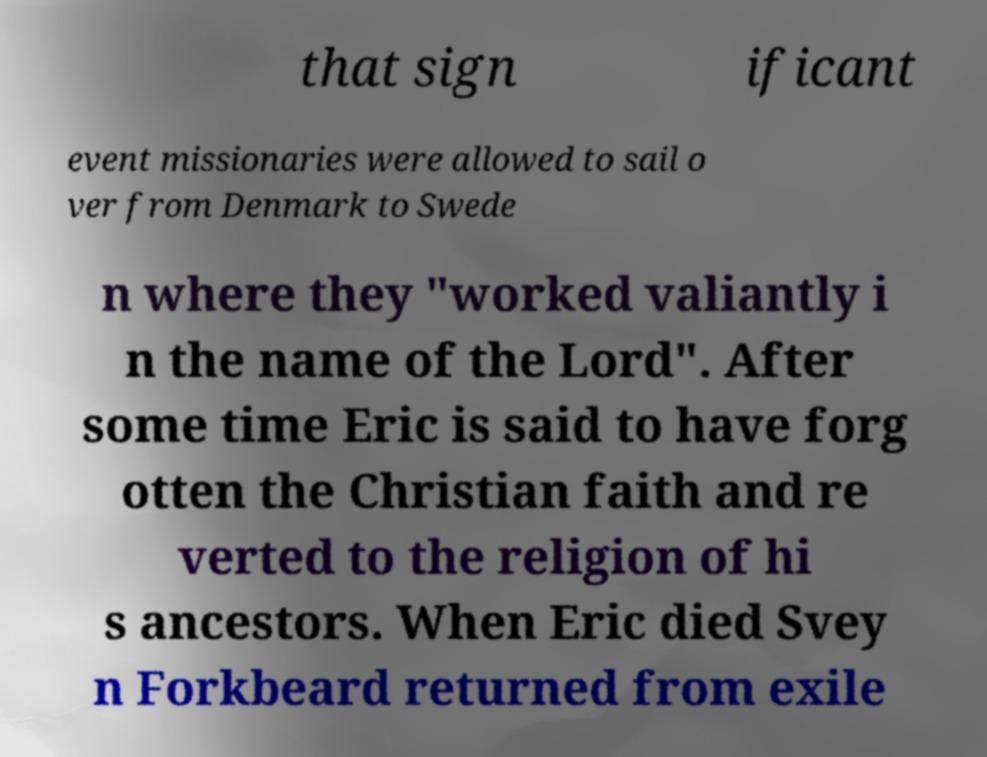Can you read and provide the text displayed in the image?This photo seems to have some interesting text. Can you extract and type it out for me? that sign ificant event missionaries were allowed to sail o ver from Denmark to Swede n where they "worked valiantly i n the name of the Lord". After some time Eric is said to have forg otten the Christian faith and re verted to the religion of hi s ancestors. When Eric died Svey n Forkbeard returned from exile 